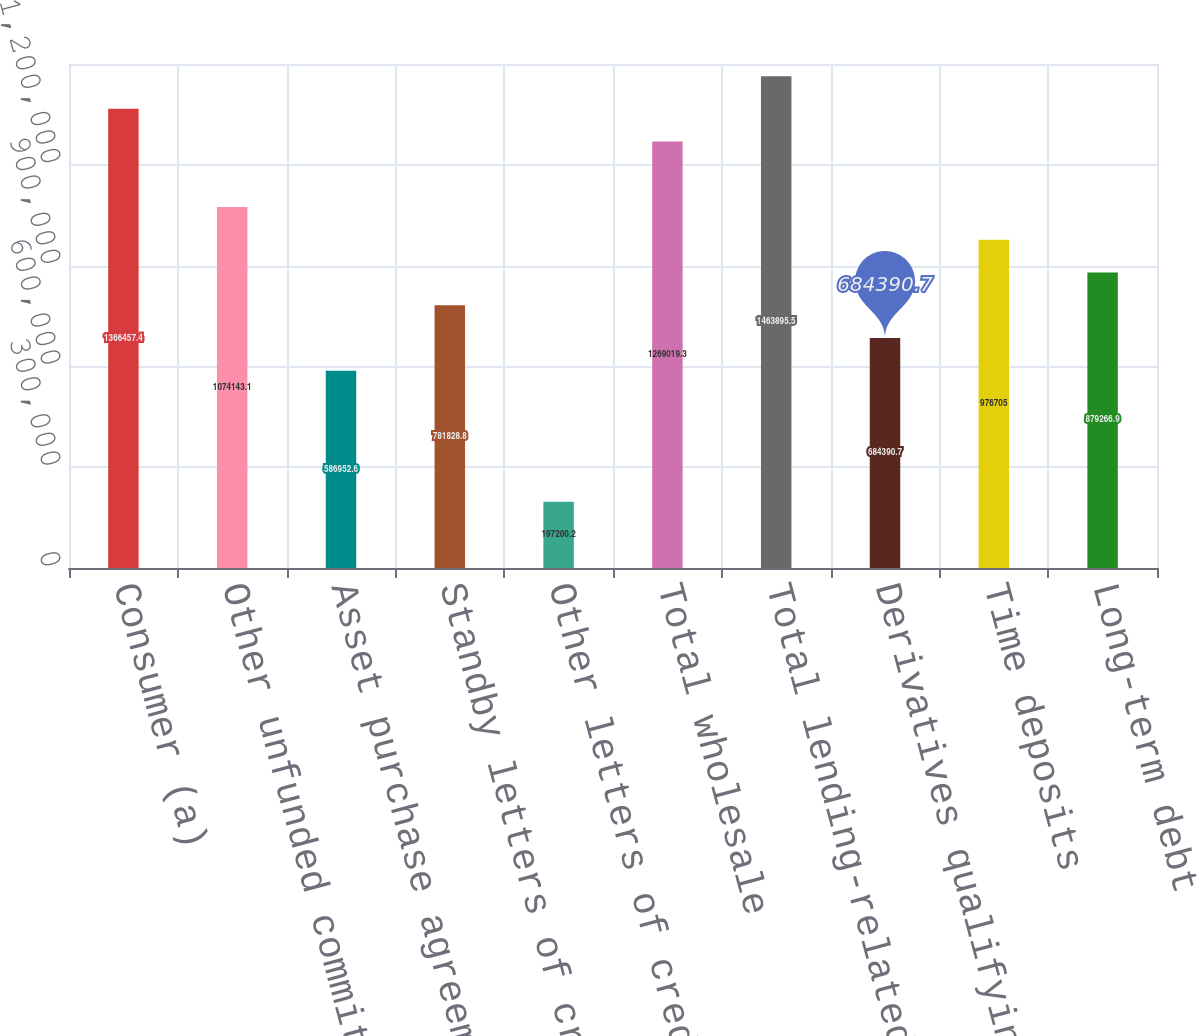Convert chart to OTSL. <chart><loc_0><loc_0><loc_500><loc_500><bar_chart><fcel>Consumer (a)<fcel>Other unfunded commitments to<fcel>Asset purchase agreements (e)<fcel>Standby letters of credit and<fcel>Other letters of credit (c)<fcel>Total wholesale<fcel>Total lending-related<fcel>Derivatives qualifying as<fcel>Time deposits<fcel>Long-term debt<nl><fcel>1.36646e+06<fcel>1.07414e+06<fcel>586953<fcel>781829<fcel>197200<fcel>1.26902e+06<fcel>1.4639e+06<fcel>684391<fcel>976705<fcel>879267<nl></chart> 